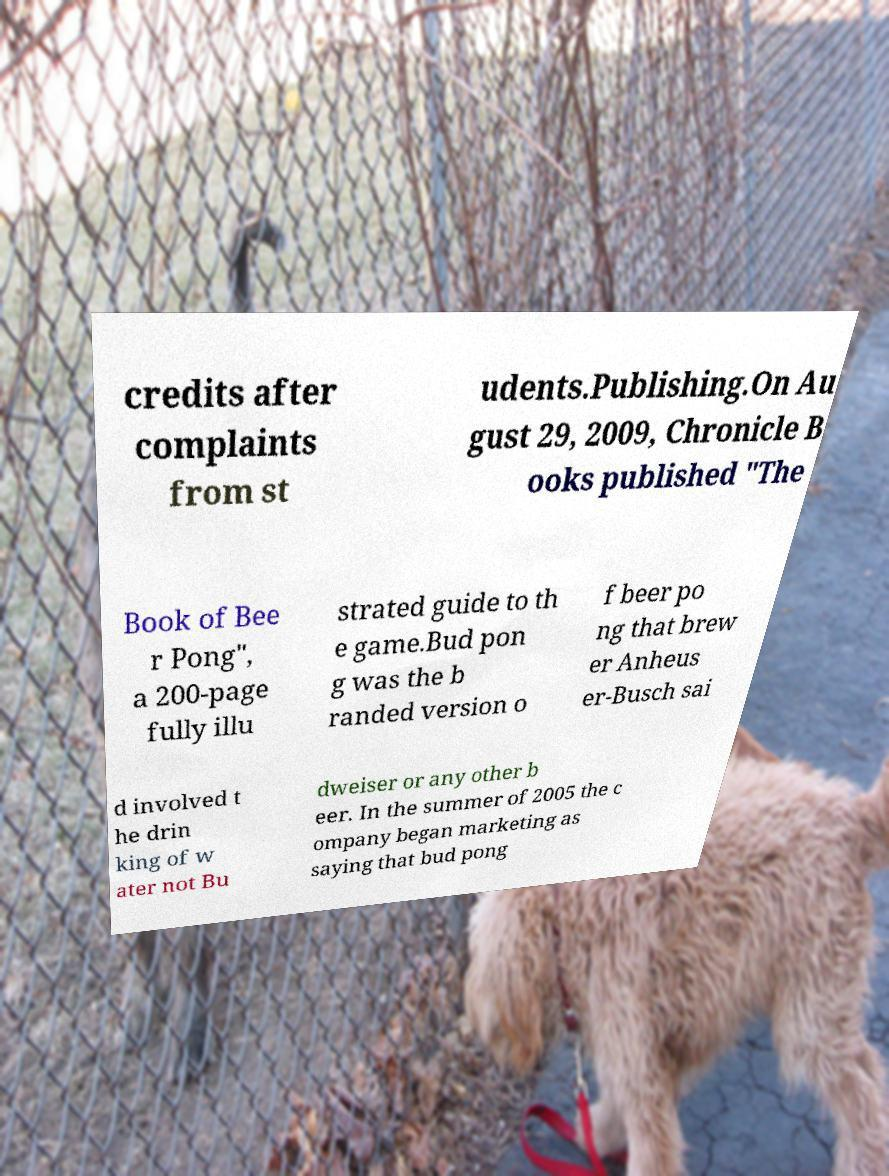Could you extract and type out the text from this image? credits after complaints from st udents.Publishing.On Au gust 29, 2009, Chronicle B ooks published "The Book of Bee r Pong", a 200-page fully illu strated guide to th e game.Bud pon g was the b randed version o f beer po ng that brew er Anheus er-Busch sai d involved t he drin king of w ater not Bu dweiser or any other b eer. In the summer of 2005 the c ompany began marketing as saying that bud pong 